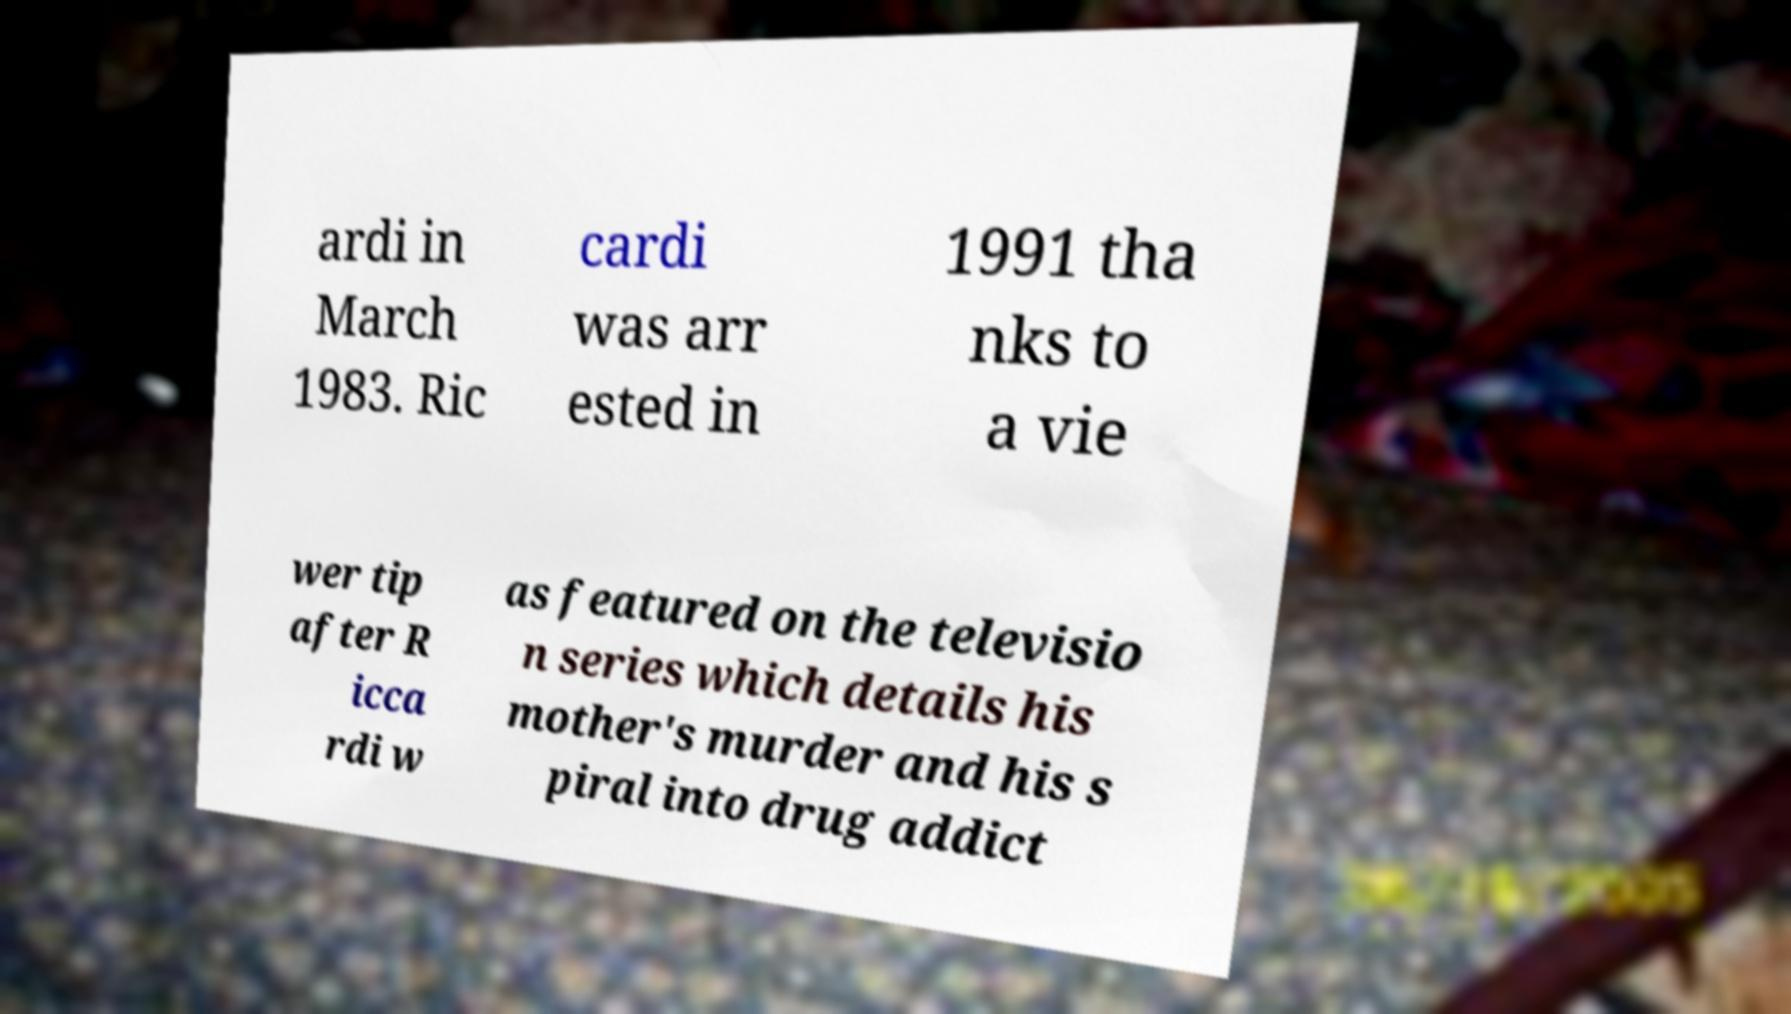Could you extract and type out the text from this image? ardi in March 1983. Ric cardi was arr ested in 1991 tha nks to a vie wer tip after R icca rdi w as featured on the televisio n series which details his mother's murder and his s piral into drug addict 